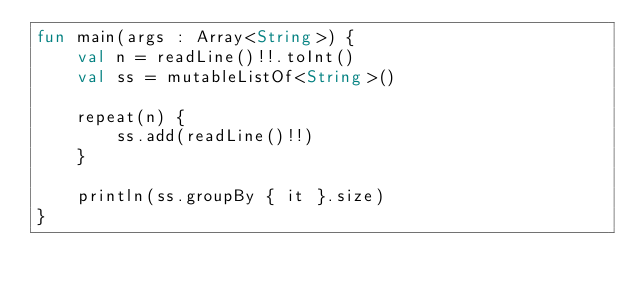Convert code to text. <code><loc_0><loc_0><loc_500><loc_500><_Kotlin_>fun main(args : Array<String>) {
    val n = readLine()!!.toInt()
    val ss = mutableListOf<String>()

    repeat(n) {
        ss.add(readLine()!!)
    }

    println(ss.groupBy { it }.size)
}</code> 